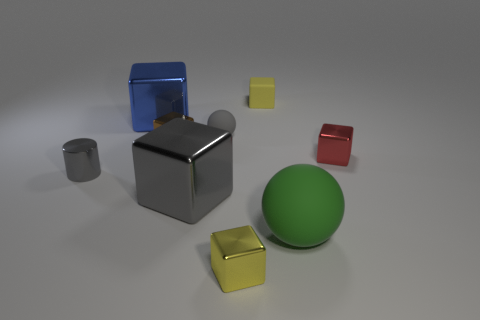Subtract all yellow cylinders. How many yellow blocks are left? 2 Subtract 3 cubes. How many cubes are left? 3 Subtract all yellow metal blocks. How many blocks are left? 5 Subtract all blue blocks. How many blocks are left? 5 Add 1 tiny yellow blocks. How many objects exist? 10 Subtract all cyan cubes. Subtract all brown cylinders. How many cubes are left? 6 Subtract all balls. How many objects are left? 7 Add 7 shiny cylinders. How many shiny cylinders are left? 8 Add 3 tiny purple cylinders. How many tiny purple cylinders exist? 3 Subtract 0 cyan cubes. How many objects are left? 9 